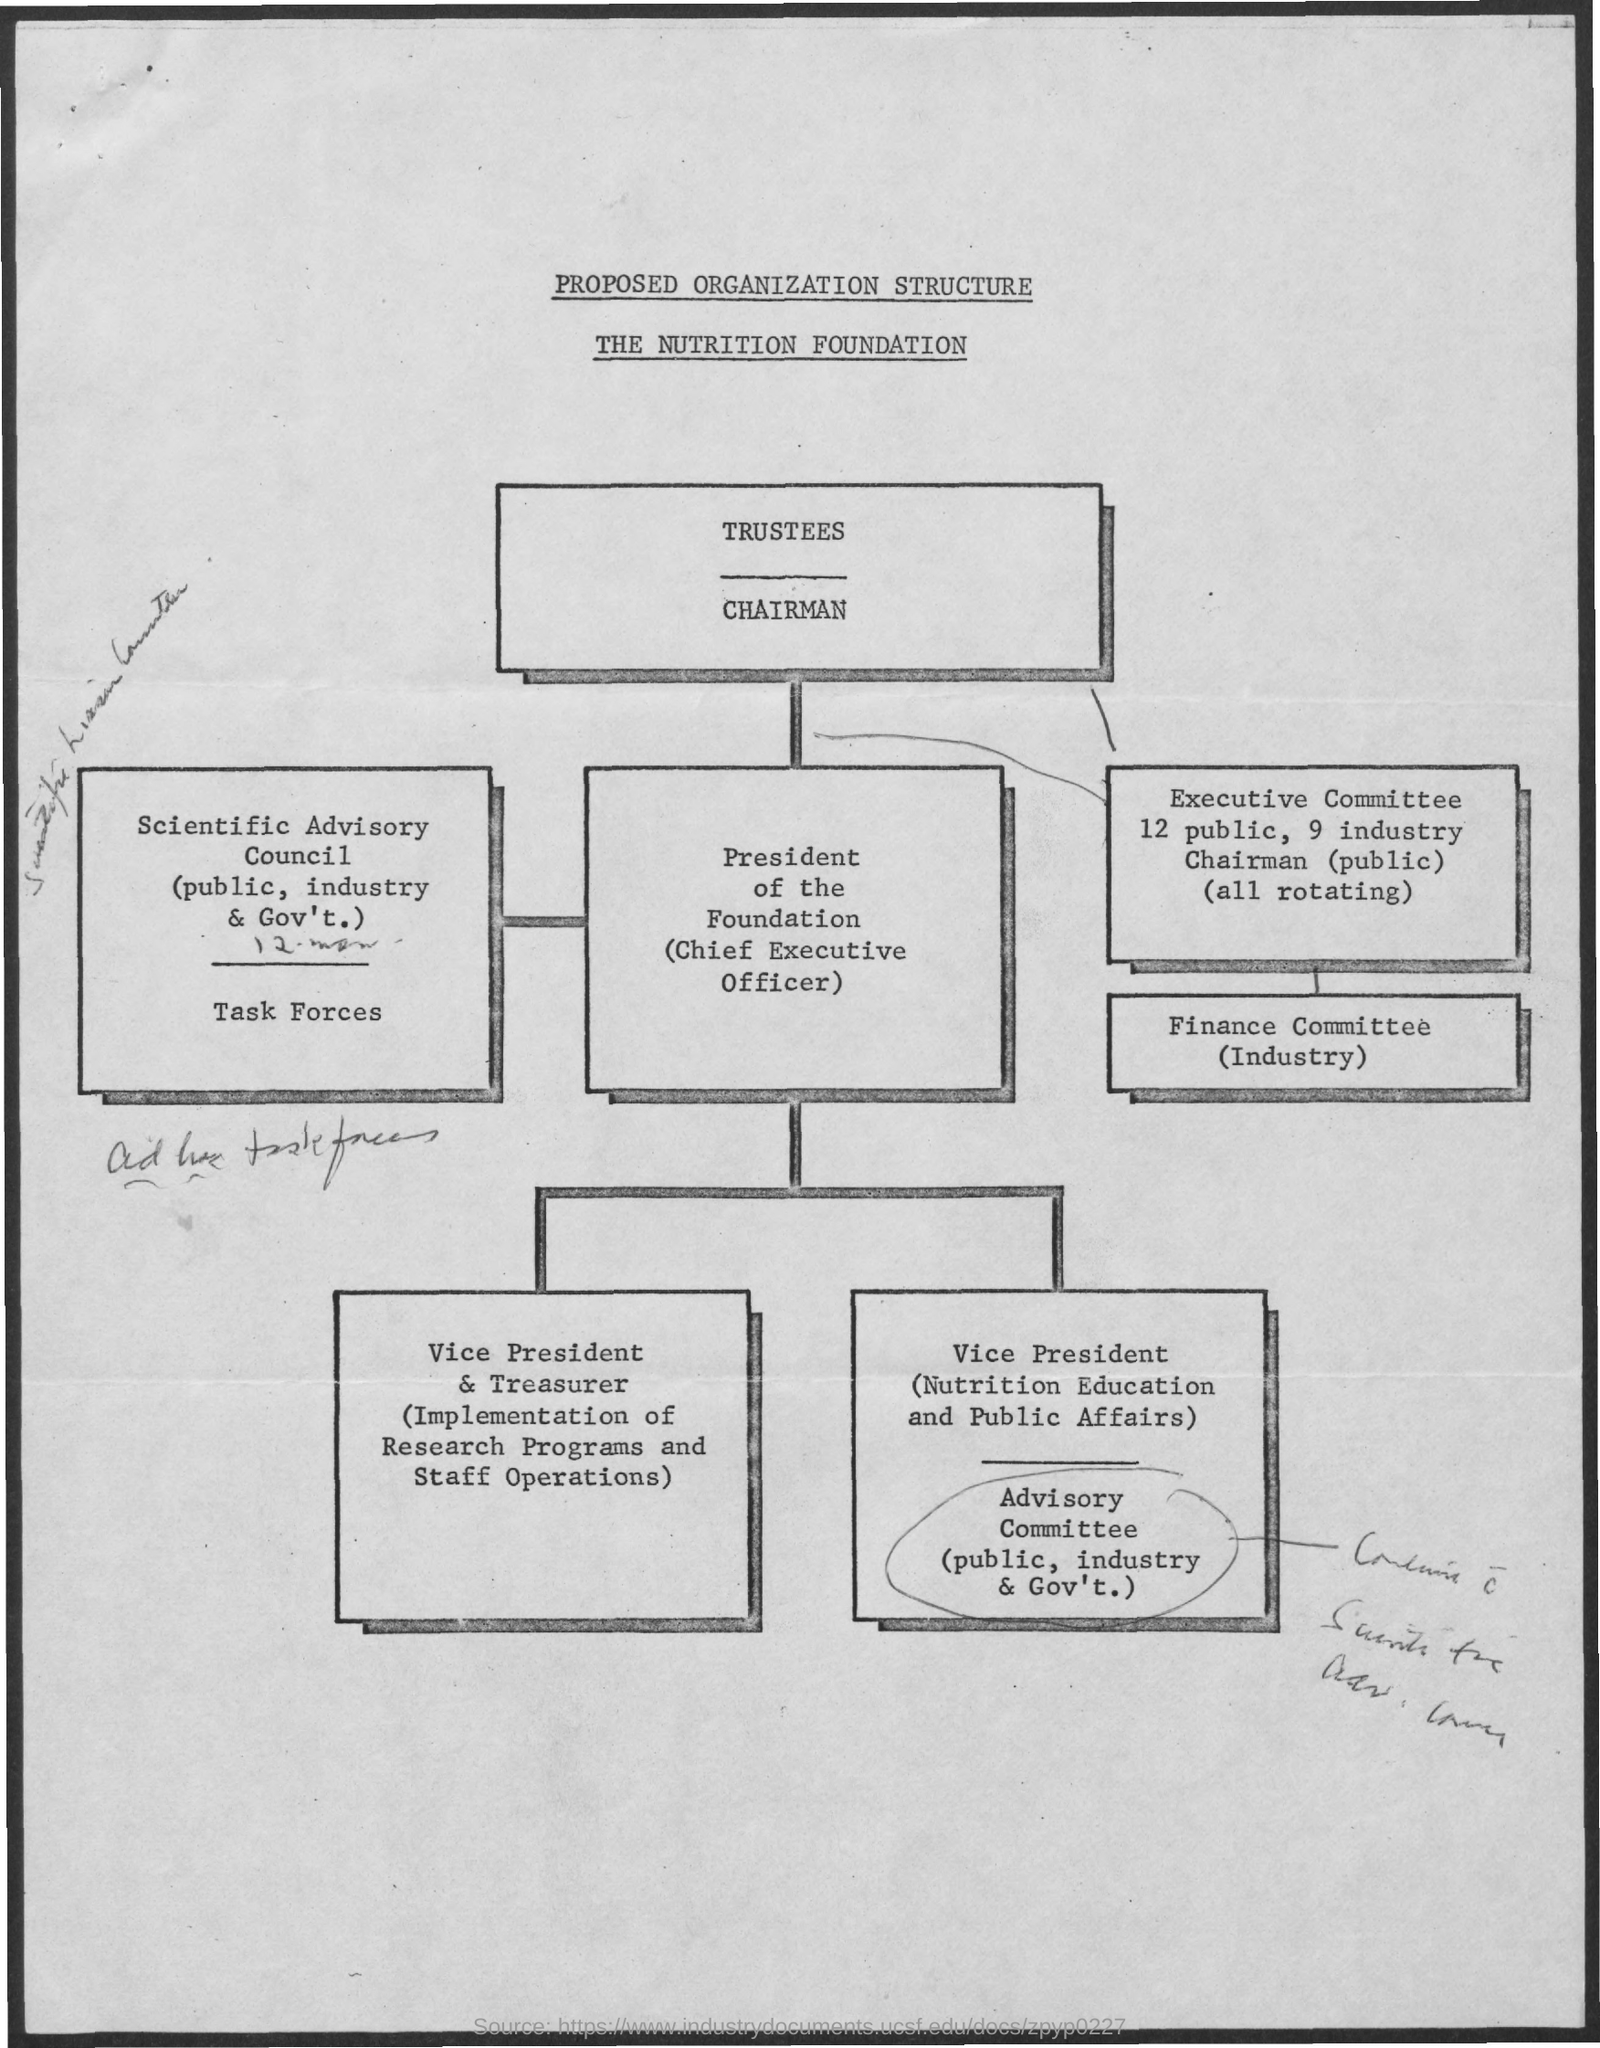Whose proposed organisation structure is this?
Provide a short and direct response. The nutrition foundation. Who deals with implementation of research programs and staff operations?
Make the answer very short. Vice president & Treasurer. 